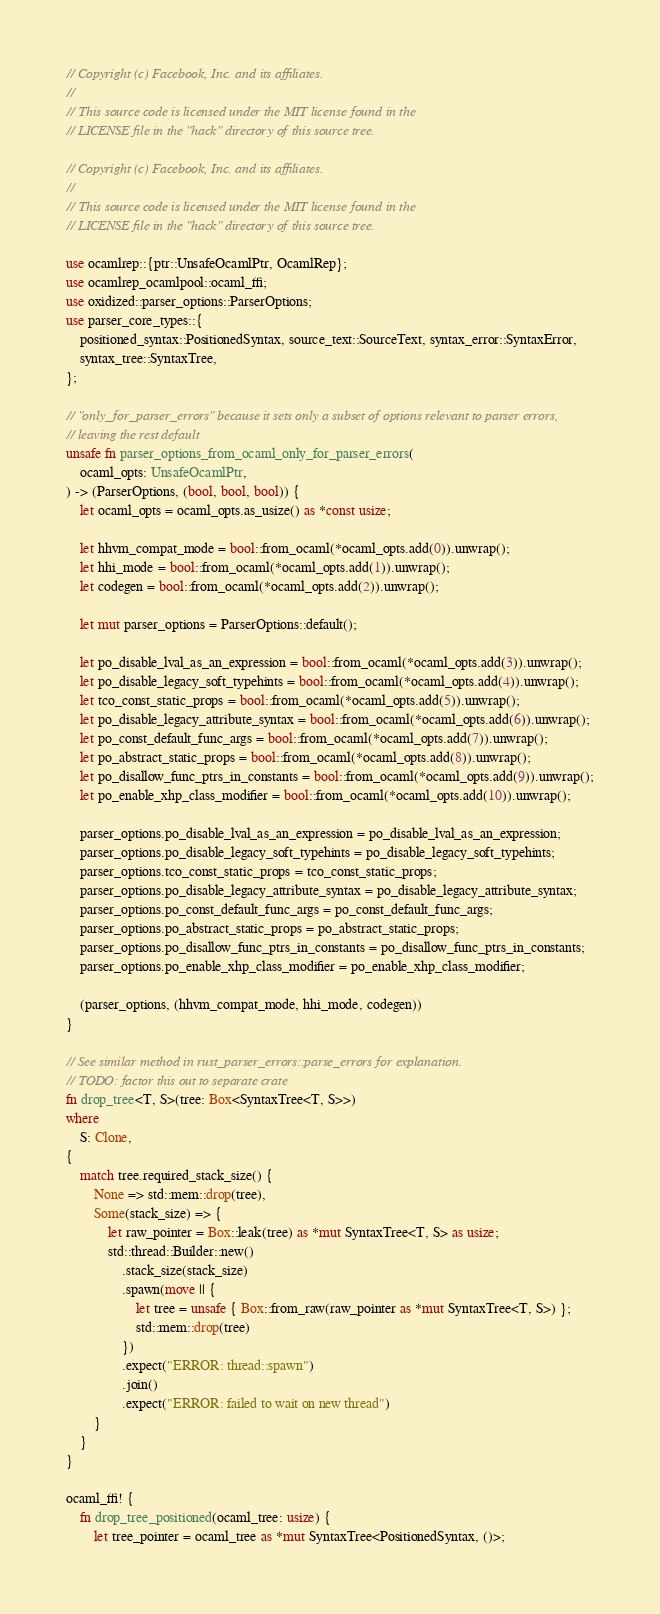<code> <loc_0><loc_0><loc_500><loc_500><_Rust_>// Copyright (c) Facebook, Inc. and its affiliates.
//
// This source code is licensed under the MIT license found in the
// LICENSE file in the "hack" directory of this source tree.

// Copyright (c) Facebook, Inc. and its affiliates.
//
// This source code is licensed under the MIT license found in the
// LICENSE file in the "hack" directory of this source tree.

use ocamlrep::{ptr::UnsafeOcamlPtr, OcamlRep};
use ocamlrep_ocamlpool::ocaml_ffi;
use oxidized::parser_options::ParserOptions;
use parser_core_types::{
    positioned_syntax::PositionedSyntax, source_text::SourceText, syntax_error::SyntaxError,
    syntax_tree::SyntaxTree,
};

// "only_for_parser_errors" because it sets only a subset of options relevant to parser errors,
// leaving the rest default
unsafe fn parser_options_from_ocaml_only_for_parser_errors(
    ocaml_opts: UnsafeOcamlPtr,
) -> (ParserOptions, (bool, bool, bool)) {
    let ocaml_opts = ocaml_opts.as_usize() as *const usize;

    let hhvm_compat_mode = bool::from_ocaml(*ocaml_opts.add(0)).unwrap();
    let hhi_mode = bool::from_ocaml(*ocaml_opts.add(1)).unwrap();
    let codegen = bool::from_ocaml(*ocaml_opts.add(2)).unwrap();

    let mut parser_options = ParserOptions::default();

    let po_disable_lval_as_an_expression = bool::from_ocaml(*ocaml_opts.add(3)).unwrap();
    let po_disable_legacy_soft_typehints = bool::from_ocaml(*ocaml_opts.add(4)).unwrap();
    let tco_const_static_props = bool::from_ocaml(*ocaml_opts.add(5)).unwrap();
    let po_disable_legacy_attribute_syntax = bool::from_ocaml(*ocaml_opts.add(6)).unwrap();
    let po_const_default_func_args = bool::from_ocaml(*ocaml_opts.add(7)).unwrap();
    let po_abstract_static_props = bool::from_ocaml(*ocaml_opts.add(8)).unwrap();
    let po_disallow_func_ptrs_in_constants = bool::from_ocaml(*ocaml_opts.add(9)).unwrap();
    let po_enable_xhp_class_modifier = bool::from_ocaml(*ocaml_opts.add(10)).unwrap();

    parser_options.po_disable_lval_as_an_expression = po_disable_lval_as_an_expression;
    parser_options.po_disable_legacy_soft_typehints = po_disable_legacy_soft_typehints;
    parser_options.tco_const_static_props = tco_const_static_props;
    parser_options.po_disable_legacy_attribute_syntax = po_disable_legacy_attribute_syntax;
    parser_options.po_const_default_func_args = po_const_default_func_args;
    parser_options.po_abstract_static_props = po_abstract_static_props;
    parser_options.po_disallow_func_ptrs_in_constants = po_disallow_func_ptrs_in_constants;
    parser_options.po_enable_xhp_class_modifier = po_enable_xhp_class_modifier;

    (parser_options, (hhvm_compat_mode, hhi_mode, codegen))
}

// See similar method in rust_parser_errors::parse_errors for explanation.
// TODO: factor this out to separate crate
fn drop_tree<T, S>(tree: Box<SyntaxTree<T, S>>)
where
    S: Clone,
{
    match tree.required_stack_size() {
        None => std::mem::drop(tree),
        Some(stack_size) => {
            let raw_pointer = Box::leak(tree) as *mut SyntaxTree<T, S> as usize;
            std::thread::Builder::new()
                .stack_size(stack_size)
                .spawn(move || {
                    let tree = unsafe { Box::from_raw(raw_pointer as *mut SyntaxTree<T, S>) };
                    std::mem::drop(tree)
                })
                .expect("ERROR: thread::spawn")
                .join()
                .expect("ERROR: failed to wait on new thread")
        }
    }
}

ocaml_ffi! {
    fn drop_tree_positioned(ocaml_tree: usize) {
        let tree_pointer = ocaml_tree as *mut SyntaxTree<PositionedSyntax, ()>;</code> 